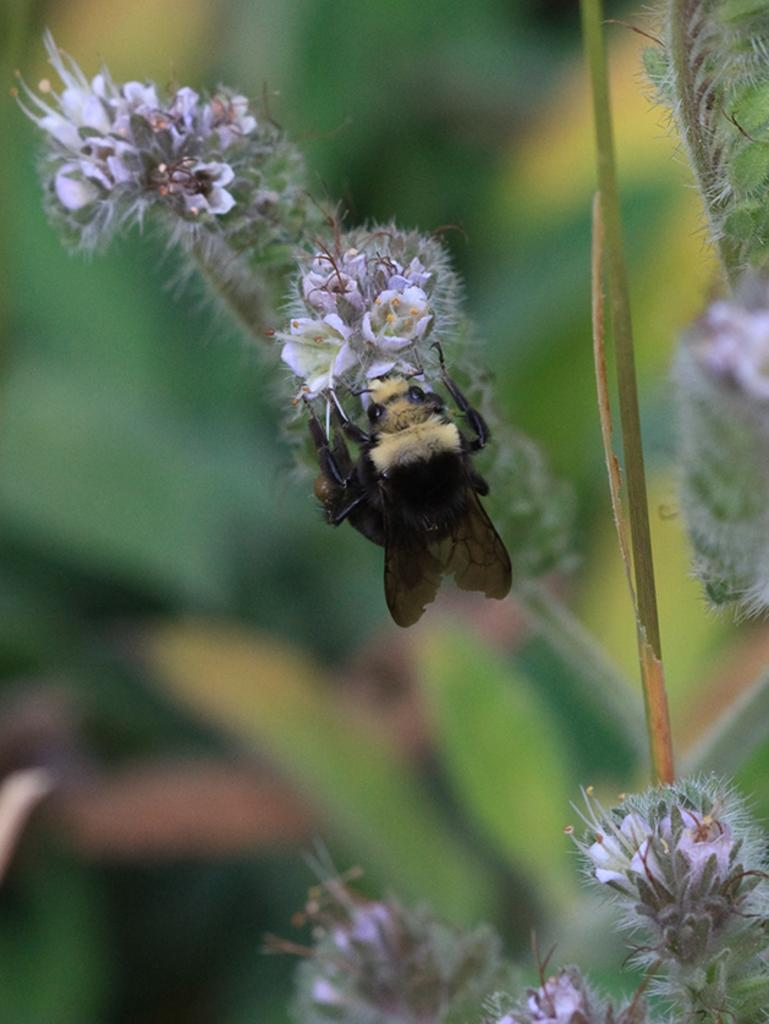What is present on the white flowers in the image? There is a fly on the white flowers in the image. Where are the white flowers located in the image? The white flowers are located in the right bottom corner of the image. What else can be seen in the background of the image? There are leaves visible in the background of the image. What type of can is visible in the image? There is no can present in the image; it features a fly on white flowers and leaves in the background. Can you see a bat flying in the image? There is no bat visible in the image. 